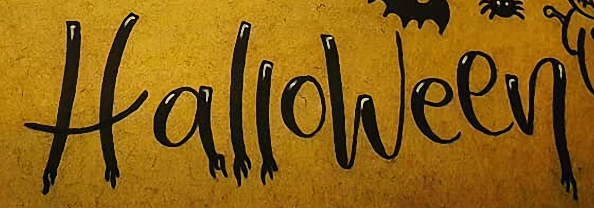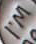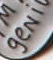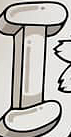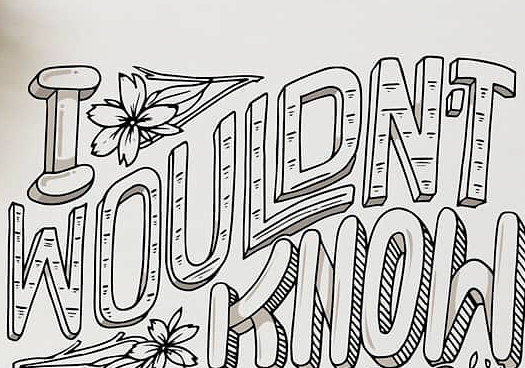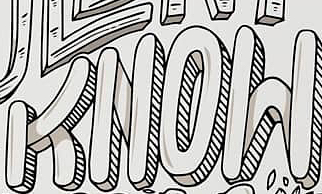What words can you see in these images in sequence, separated by a semicolon? Halloween; I'M; geNi; I; WOULDN'T; KNOW 